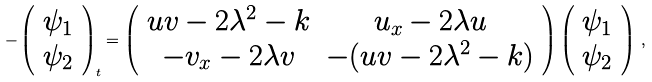<formula> <loc_0><loc_0><loc_500><loc_500>- \left ( \begin{array} { c } \psi _ { 1 } \\ \psi _ { 2 } \end{array} \right ) _ { t } = \left ( \begin{array} { c c } u v - 2 \lambda ^ { 2 } - k & u _ { x } - 2 \lambda u \\ - v _ { x } - 2 \lambda v & - ( u v - 2 \lambda ^ { 2 } - k ) \end{array} \right ) \left ( \begin{array} { c } \psi _ { 1 } \\ \psi _ { 2 } \end{array} \right ) \, ,</formula> 